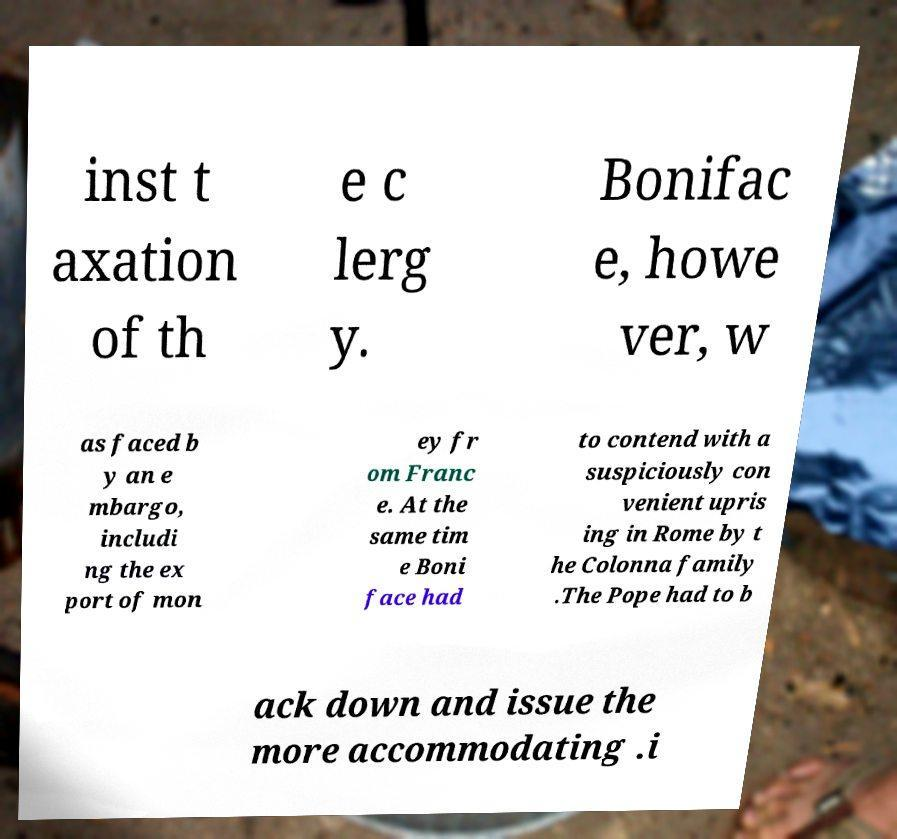Could you assist in decoding the text presented in this image and type it out clearly? inst t axation of th e c lerg y. Bonifac e, howe ver, w as faced b y an e mbargo, includi ng the ex port of mon ey fr om Franc e. At the same tim e Boni face had to contend with a suspiciously con venient upris ing in Rome by t he Colonna family .The Pope had to b ack down and issue the more accommodating .i 